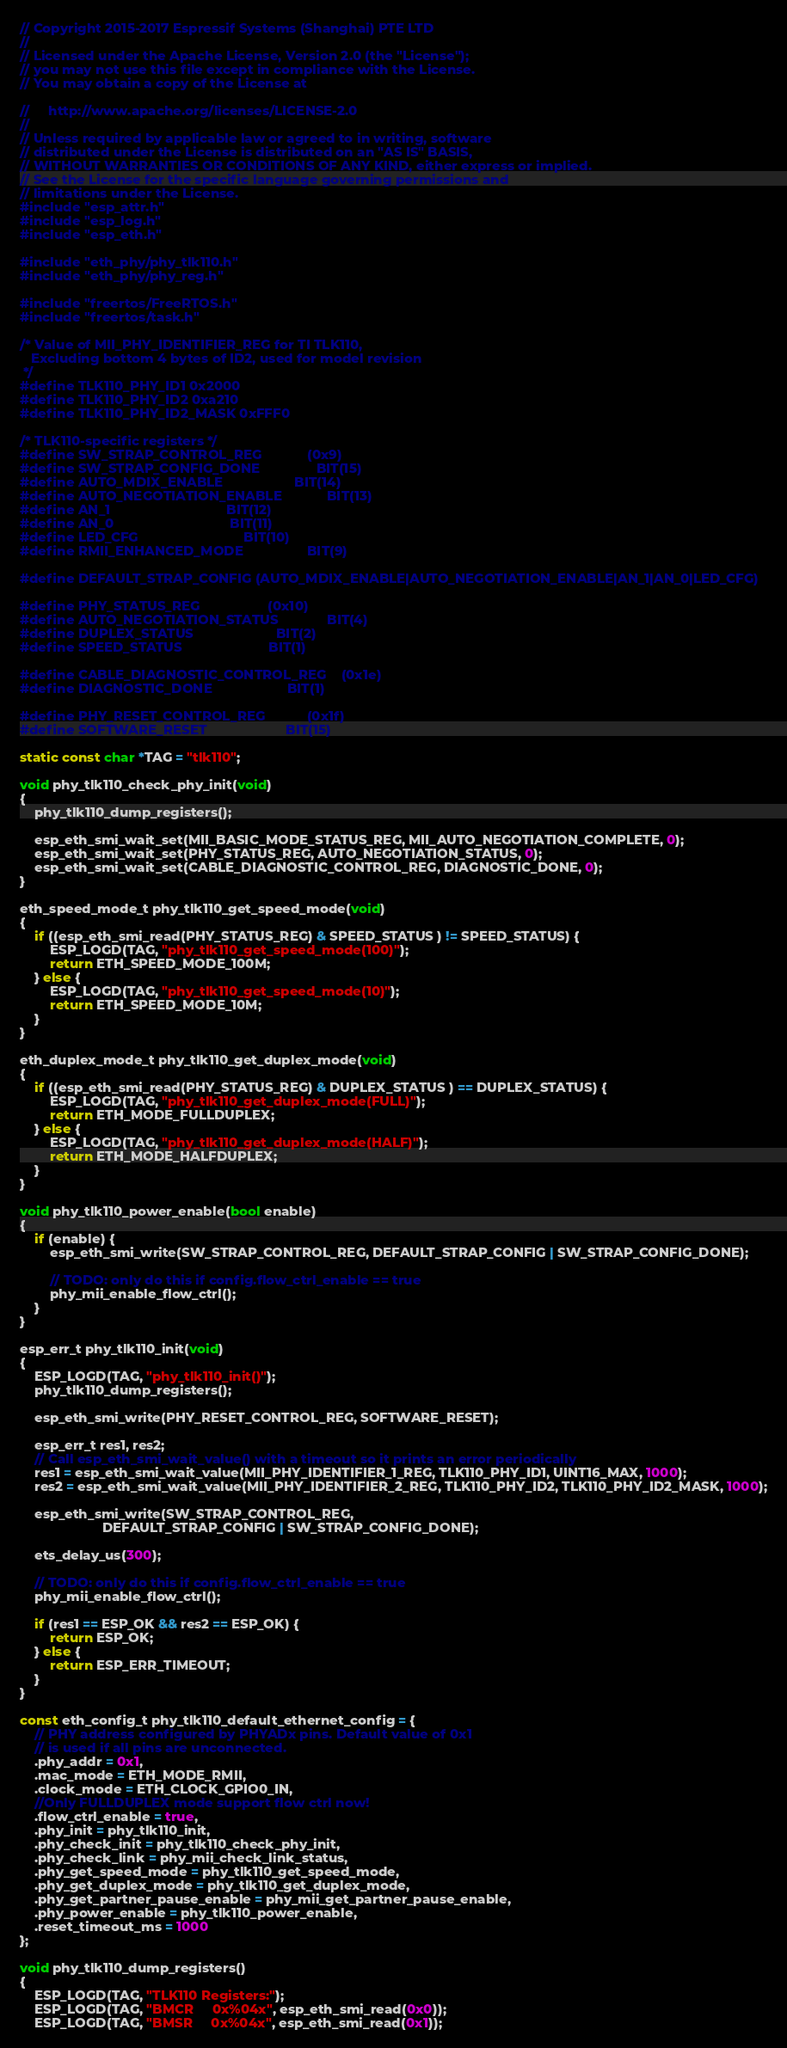<code> <loc_0><loc_0><loc_500><loc_500><_C_>// Copyright 2015-2017 Espressif Systems (Shanghai) PTE LTD
//
// Licensed under the Apache License, Version 2.0 (the "License");
// you may not use this file except in compliance with the License.
// You may obtain a copy of the License at

//     http://www.apache.org/licenses/LICENSE-2.0
//
// Unless required by applicable law or agreed to in writing, software
// distributed under the License is distributed on an "AS IS" BASIS,
// WITHOUT WARRANTIES OR CONDITIONS OF ANY KIND, either express or implied.
// See the License for the specific language governing permissions and
// limitations under the License.
#include "esp_attr.h"
#include "esp_log.h"
#include "esp_eth.h"

#include "eth_phy/phy_tlk110.h"
#include "eth_phy/phy_reg.h"

#include "freertos/FreeRTOS.h"
#include "freertos/task.h"

/* Value of MII_PHY_IDENTIFIER_REG for TI TLK110,
   Excluding bottom 4 bytes of ID2, used for model revision
 */
#define TLK110_PHY_ID1 0x2000
#define TLK110_PHY_ID2 0xa210
#define TLK110_PHY_ID2_MASK 0xFFF0

/* TLK110-specific registers */
#define SW_STRAP_CONTROL_REG            (0x9)
#define SW_STRAP_CONFIG_DONE               BIT(15)
#define AUTO_MDIX_ENABLE                   BIT(14)
#define AUTO_NEGOTIATION_ENABLE            BIT(13)
#define AN_1                               BIT(12)
#define AN_0                               BIT(11)
#define LED_CFG                            BIT(10)
#define RMII_ENHANCED_MODE                 BIT(9)

#define DEFAULT_STRAP_CONFIG (AUTO_MDIX_ENABLE|AUTO_NEGOTIATION_ENABLE|AN_1|AN_0|LED_CFG)

#define PHY_STATUS_REG                  (0x10)
#define AUTO_NEGOTIATION_STATUS             BIT(4)
#define DUPLEX_STATUS                      BIT(2)
#define SPEED_STATUS                       BIT(1)

#define CABLE_DIAGNOSTIC_CONTROL_REG    (0x1e)
#define DIAGNOSTIC_DONE                    BIT(1)

#define PHY_RESET_CONTROL_REG           (0x1f)
#define SOFTWARE_RESET                     BIT(15)

static const char *TAG = "tlk110";

void phy_tlk110_check_phy_init(void)
{
    phy_tlk110_dump_registers();

    esp_eth_smi_wait_set(MII_BASIC_MODE_STATUS_REG, MII_AUTO_NEGOTIATION_COMPLETE, 0);
    esp_eth_smi_wait_set(PHY_STATUS_REG, AUTO_NEGOTIATION_STATUS, 0);
    esp_eth_smi_wait_set(CABLE_DIAGNOSTIC_CONTROL_REG, DIAGNOSTIC_DONE, 0);
}

eth_speed_mode_t phy_tlk110_get_speed_mode(void)
{
    if ((esp_eth_smi_read(PHY_STATUS_REG) & SPEED_STATUS ) != SPEED_STATUS) {
        ESP_LOGD(TAG, "phy_tlk110_get_speed_mode(100)");
        return ETH_SPEED_MODE_100M;
    } else {
        ESP_LOGD(TAG, "phy_tlk110_get_speed_mode(10)");
        return ETH_SPEED_MODE_10M;
    }
}

eth_duplex_mode_t phy_tlk110_get_duplex_mode(void)
{
    if ((esp_eth_smi_read(PHY_STATUS_REG) & DUPLEX_STATUS ) == DUPLEX_STATUS) {
        ESP_LOGD(TAG, "phy_tlk110_get_duplex_mode(FULL)");
        return ETH_MODE_FULLDUPLEX;
    } else {
        ESP_LOGD(TAG, "phy_tlk110_get_duplex_mode(HALF)");
        return ETH_MODE_HALFDUPLEX;
    }
}

void phy_tlk110_power_enable(bool enable)
{
    if (enable) {
        esp_eth_smi_write(SW_STRAP_CONTROL_REG, DEFAULT_STRAP_CONFIG | SW_STRAP_CONFIG_DONE);

        // TODO: only do this if config.flow_ctrl_enable == true
        phy_mii_enable_flow_ctrl();
    }
}

esp_err_t phy_tlk110_init(void)
{
    ESP_LOGD(TAG, "phy_tlk110_init()");
    phy_tlk110_dump_registers();

    esp_eth_smi_write(PHY_RESET_CONTROL_REG, SOFTWARE_RESET);

    esp_err_t res1, res2;
    // Call esp_eth_smi_wait_value() with a timeout so it prints an error periodically
    res1 = esp_eth_smi_wait_value(MII_PHY_IDENTIFIER_1_REG, TLK110_PHY_ID1, UINT16_MAX, 1000);
    res2 = esp_eth_smi_wait_value(MII_PHY_IDENTIFIER_2_REG, TLK110_PHY_ID2, TLK110_PHY_ID2_MASK, 1000);

    esp_eth_smi_write(SW_STRAP_CONTROL_REG,
                      DEFAULT_STRAP_CONFIG | SW_STRAP_CONFIG_DONE);

    ets_delay_us(300);

    // TODO: only do this if config.flow_ctrl_enable == true
    phy_mii_enable_flow_ctrl();

    if (res1 == ESP_OK && res2 == ESP_OK) {
        return ESP_OK;
    } else {
        return ESP_ERR_TIMEOUT;
    }
}

const eth_config_t phy_tlk110_default_ethernet_config = {
    // PHY address configured by PHYADx pins. Default value of 0x1
    // is used if all pins are unconnected.
    .phy_addr = 0x1,
    .mac_mode = ETH_MODE_RMII,
    .clock_mode = ETH_CLOCK_GPIO0_IN,
    //Only FULLDUPLEX mode support flow ctrl now!
    .flow_ctrl_enable = true,
    .phy_init = phy_tlk110_init,
    .phy_check_init = phy_tlk110_check_phy_init,
    .phy_check_link = phy_mii_check_link_status,
    .phy_get_speed_mode = phy_tlk110_get_speed_mode,
    .phy_get_duplex_mode = phy_tlk110_get_duplex_mode,
    .phy_get_partner_pause_enable = phy_mii_get_partner_pause_enable,
    .phy_power_enable = phy_tlk110_power_enable,
    .reset_timeout_ms = 1000
};

void phy_tlk110_dump_registers()
{
    ESP_LOGD(TAG, "TLK110 Registers:");
    ESP_LOGD(TAG, "BMCR     0x%04x", esp_eth_smi_read(0x0));
    ESP_LOGD(TAG, "BMSR     0x%04x", esp_eth_smi_read(0x1));</code> 